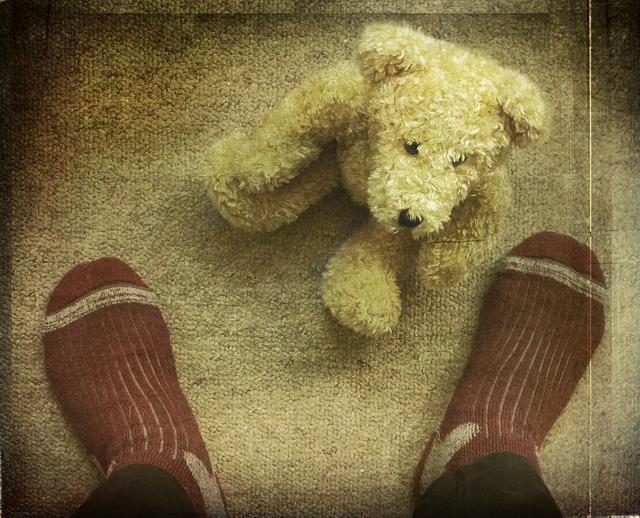How many bears are there?
Give a very brief answer. 1. How many spokes does the car rim have?
Give a very brief answer. 0. 